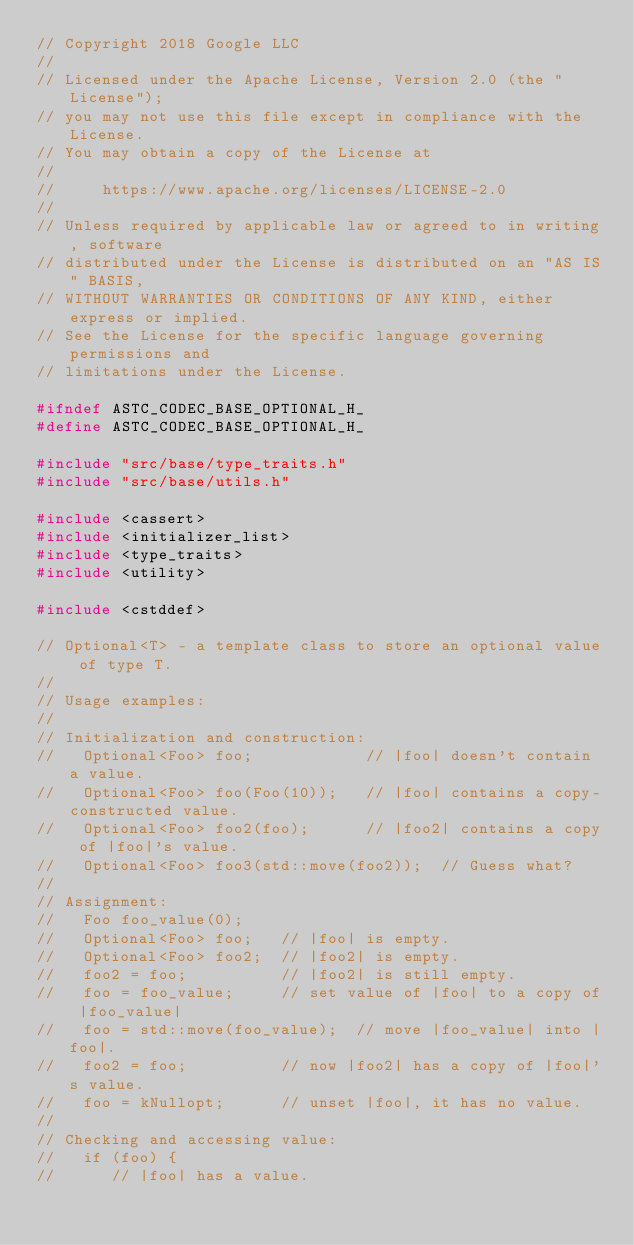Convert code to text. <code><loc_0><loc_0><loc_500><loc_500><_C_>// Copyright 2018 Google LLC
//
// Licensed under the Apache License, Version 2.0 (the "License");
// you may not use this file except in compliance with the License.
// You may obtain a copy of the License at
//
//     https://www.apache.org/licenses/LICENSE-2.0
//
// Unless required by applicable law or agreed to in writing, software
// distributed under the License is distributed on an "AS IS" BASIS,
// WITHOUT WARRANTIES OR CONDITIONS OF ANY KIND, either express or implied.
// See the License for the specific language governing permissions and
// limitations under the License.

#ifndef ASTC_CODEC_BASE_OPTIONAL_H_
#define ASTC_CODEC_BASE_OPTIONAL_H_

#include "src/base/type_traits.h"
#include "src/base/utils.h"

#include <cassert>
#include <initializer_list>
#include <type_traits>
#include <utility>

#include <cstddef>

// Optional<T> - a template class to store an optional value of type T.
//
// Usage examples:
//
// Initialization and construction:
//   Optional<Foo> foo;            // |foo| doesn't contain a value.
//   Optional<Foo> foo(Foo(10));   // |foo| contains a copy-constructed value.
//   Optional<Foo> foo2(foo);      // |foo2| contains a copy of |foo|'s value.
//   Optional<Foo> foo3(std::move(foo2));  // Guess what?
//
// Assignment:
//   Foo foo_value(0);
//   Optional<Foo> foo;   // |foo| is empty.
//   Optional<Foo> foo2;  // |foo2| is empty.
//   foo2 = foo;          // |foo2| is still empty.
//   foo = foo_value;     // set value of |foo| to a copy of |foo_value|
//   foo = std::move(foo_value);  // move |foo_value| into |foo|.
//   foo2 = foo;          // now |foo2| has a copy of |foo|'s value.
//   foo = kNullopt;      // unset |foo|, it has no value.
//
// Checking and accessing value:
//   if (foo) {
//      // |foo| has a value.</code> 